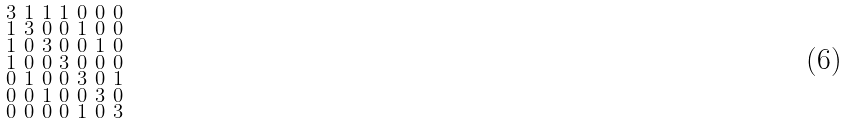Convert formula to latex. <formula><loc_0><loc_0><loc_500><loc_500>\begin{smallmatrix} 3 & 1 & 1 & 1 & 0 & 0 & 0 \\ 1 & 3 & 0 & 0 & 1 & 0 & 0 \\ 1 & 0 & 3 & 0 & 0 & 1 & 0 \\ 1 & 0 & 0 & 3 & 0 & 0 & 0 \\ 0 & 1 & 0 & 0 & 3 & 0 & 1 \\ 0 & 0 & 1 & 0 & 0 & 3 & 0 \\ 0 & 0 & 0 & 0 & 1 & 0 & 3 \end{smallmatrix}</formula> 